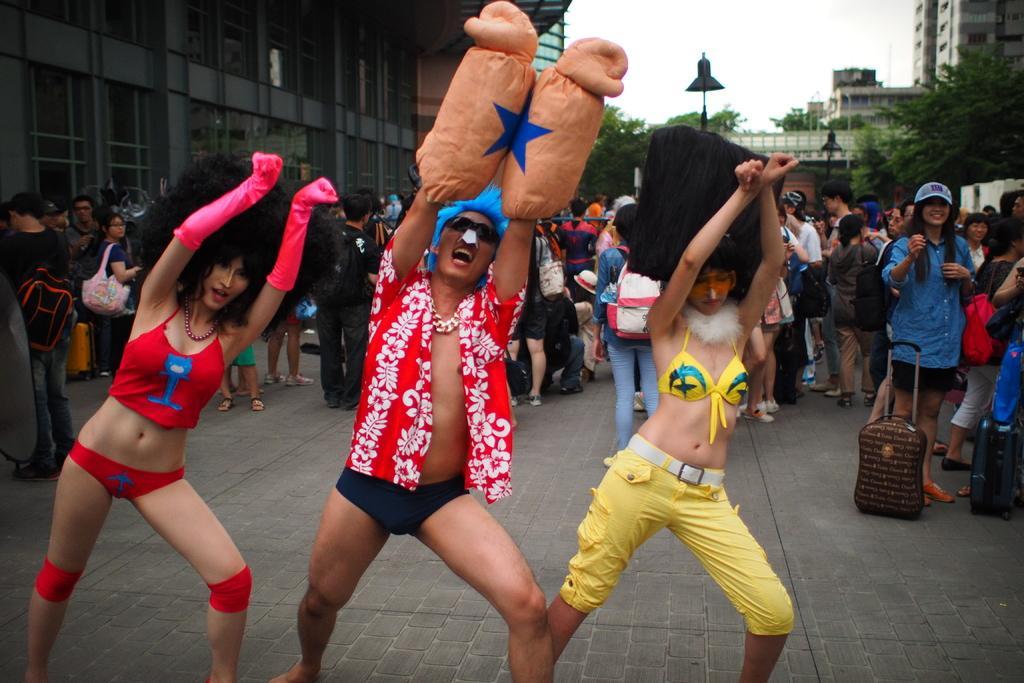Can you describe this image briefly? In this image, in the middle, we can see three people are dancing. In the background, we can see a group of people, few people are walking, few people sitting, few people are standing on the floor. On the right side, we can see some trees, building, lights. On the left side, we can also see some buildings. At the top, we can see a sky, at the bottom, we can see a land. 